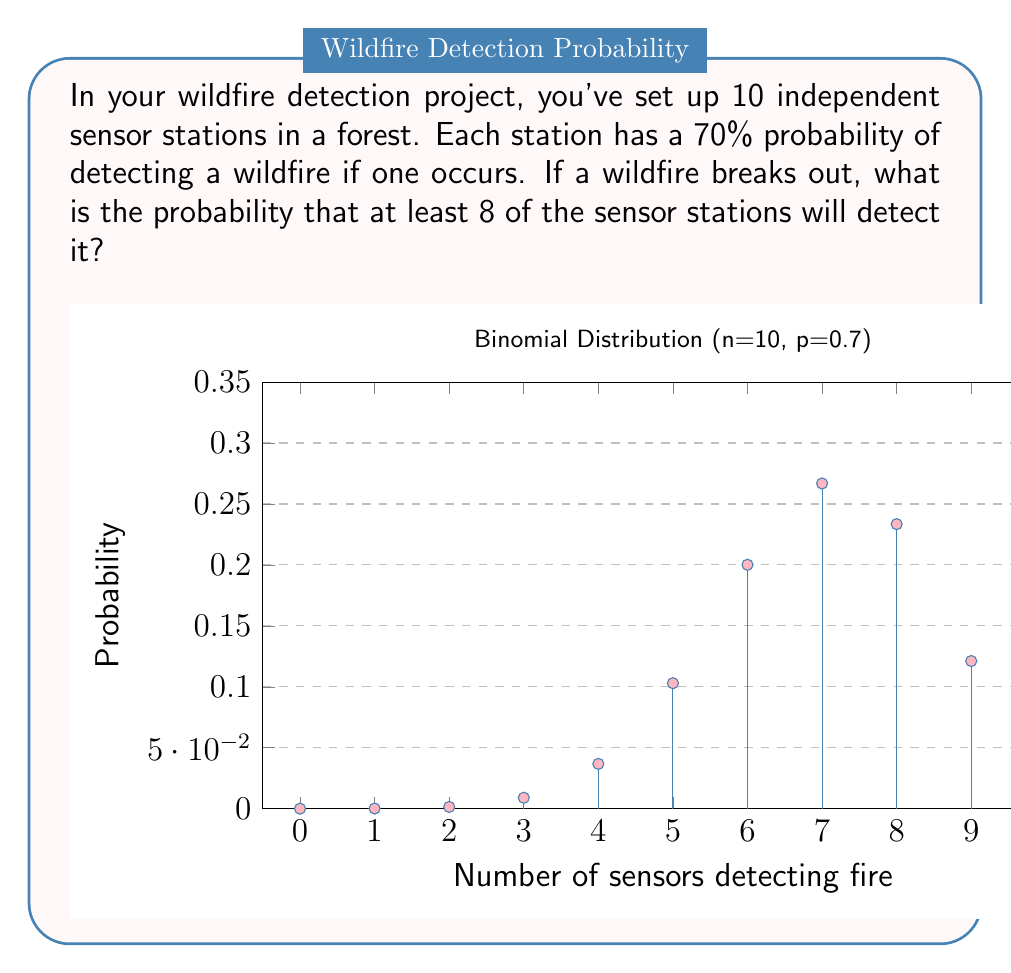Could you help me with this problem? Let's approach this step-by-step using the binomial distribution:

1) We have a binomial distribution with parameters:
   $n = 10$ (number of sensor stations)
   $p = 0.7$ (probability of each station detecting the fire)

2) We want the probability of at least 8 stations detecting the fire. This means we need to sum the probabilities for 8, 9, and 10 stations detecting the fire.

3) The probability mass function for a binomial distribution is:

   $$P(X = k) = \binom{n}{k} p^k (1-p)^{n-k}$$

4) Let's calculate each probability:

   For 8 stations: 
   $$P(X = 8) = \binom{10}{8} (0.7)^8 (0.3)^2 = 45 \times 0.5764801 \times 0.09 = 0.2334744$$

   For 9 stations:
   $$P(X = 9) = \binom{10}{9} (0.7)^9 (0.3)^1 = 10 \times 0.4038361 \times 0.3 = 0.1211508$$

   For 10 stations:
   $$P(X = 10) = \binom{10}{10} (0.7)^{10} (0.3)^0 = 1 \times 0.2824295 \times 1 = 0.0282430$$

5) The probability of at least 8 stations detecting the fire is the sum of these probabilities:

   $$P(X \geq 8) = P(X = 8) + P(X = 9) + P(X = 10)$$
   $$= 0.2334744 + 0.1211508 + 0.0282430 = 0.3828682$$

6) Therefore, the probability is approximately 0.3829 or 38.29%.
Answer: 0.3829 